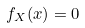Convert formula to latex. <formula><loc_0><loc_0><loc_500><loc_500>f _ { X } ( x ) = 0</formula> 